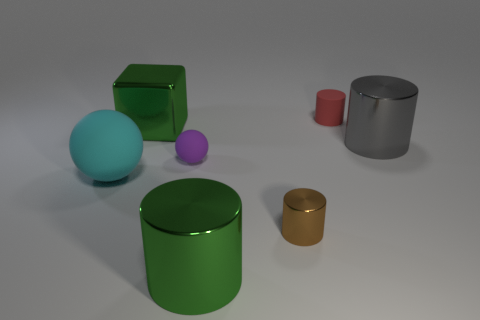Add 2 purple metallic cylinders. How many objects exist? 9 Subtract 1 cylinders. How many cylinders are left? 3 Subtract all large green cylinders. How many cylinders are left? 3 Subtract all cubes. How many objects are left? 6 Add 4 large cyan shiny cubes. How many large cyan shiny cubes exist? 4 Subtract 0 green spheres. How many objects are left? 7 Subtract all purple cylinders. Subtract all gray spheres. How many cylinders are left? 4 Subtract all big red shiny spheres. Subtract all brown things. How many objects are left? 6 Add 5 big balls. How many big balls are left? 6 